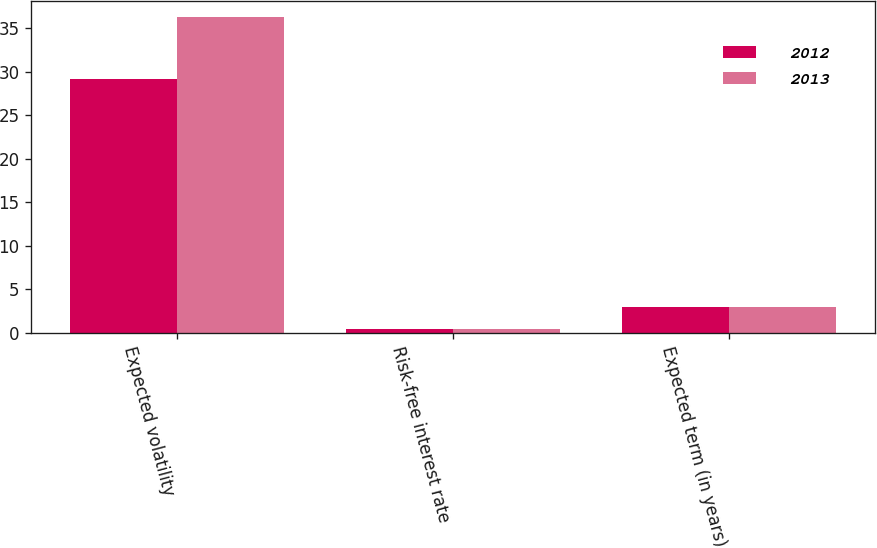Convert chart to OTSL. <chart><loc_0><loc_0><loc_500><loc_500><stacked_bar_chart><ecel><fcel>Expected volatility<fcel>Risk-free interest rate<fcel>Expected term (in years)<nl><fcel>2012<fcel>29.18<fcel>0.42<fcel>3<nl><fcel>2013<fcel>36.3<fcel>0.42<fcel>3<nl></chart> 